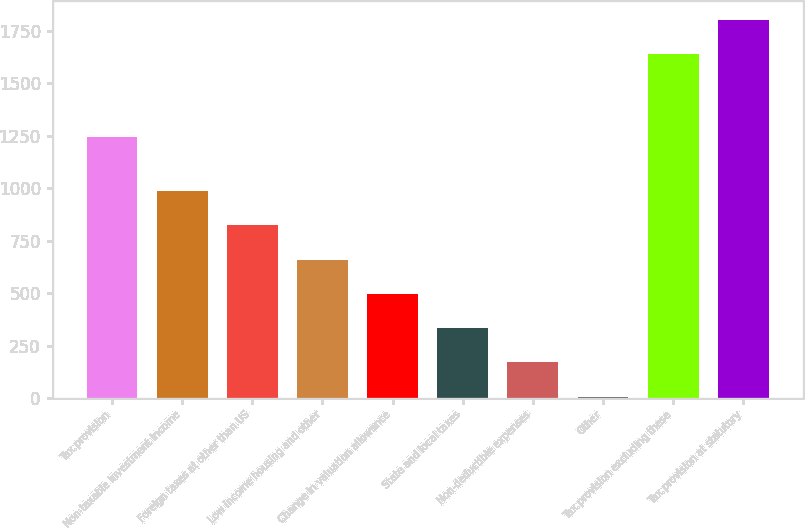Convert chart. <chart><loc_0><loc_0><loc_500><loc_500><bar_chart><fcel>Tax provision<fcel>Non-taxable investment income<fcel>Foreign taxes at other than US<fcel>Low income housing and other<fcel>Change in valuation allowance<fcel>State and local taxes<fcel>Non-deductible expenses<fcel>Other<fcel>Tax provision excluding these<fcel>Tax provision at statutory<nl><fcel>1245<fcel>986.4<fcel>823<fcel>659.6<fcel>496.2<fcel>332.8<fcel>169.4<fcel>6<fcel>1640<fcel>1803.4<nl></chart> 